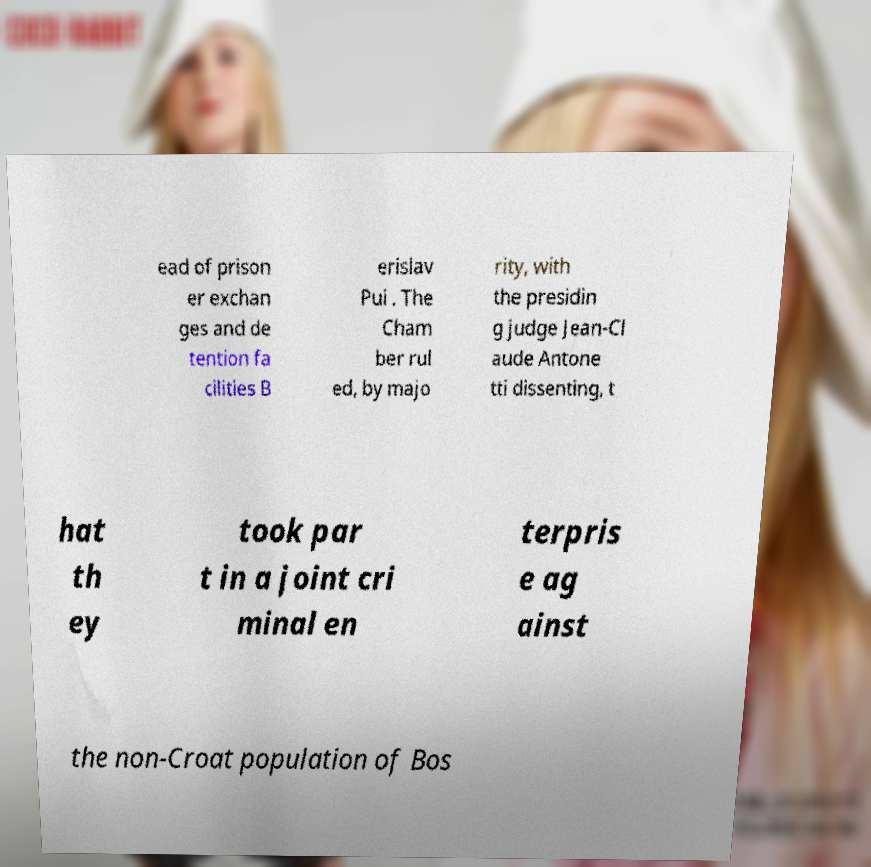Can you accurately transcribe the text from the provided image for me? ead of prison er exchan ges and de tention fa cilities B erislav Pui . The Cham ber rul ed, by majo rity, with the presidin g judge Jean-Cl aude Antone tti dissenting, t hat th ey took par t in a joint cri minal en terpris e ag ainst the non-Croat population of Bos 